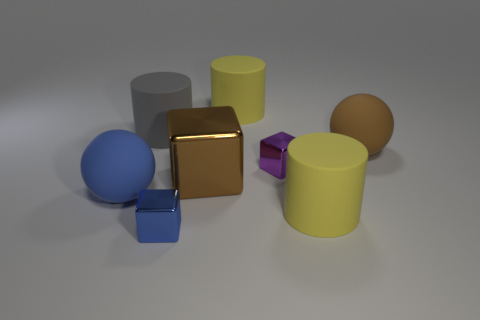Is there anything else that is the same size as the blue metal thing?
Make the answer very short. Yes. Are there any big metallic cubes in front of the large blue object?
Keep it short and to the point. No. The tiny purple shiny thing is what shape?
Your answer should be very brief. Cube. How many things are brown things that are right of the large gray rubber object or big gray matte objects?
Provide a short and direct response. 3. Do the large block and the big matte cylinder in front of the big gray thing have the same color?
Keep it short and to the point. No. What color is the other big metallic thing that is the same shape as the blue metal object?
Give a very brief answer. Brown. Is the large gray thing made of the same material as the large yellow object that is behind the big brown cube?
Your response must be concise. Yes. The large metallic cube is what color?
Provide a succinct answer. Brown. There is a large cylinder in front of the large cylinder that is on the left side of the small metallic object that is on the left side of the tiny purple object; what color is it?
Your answer should be very brief. Yellow. Does the big metal object have the same shape as the yellow rubber object that is behind the tiny purple cube?
Provide a succinct answer. No. 